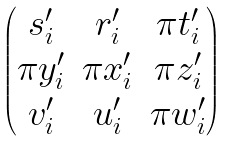Convert formula to latex. <formula><loc_0><loc_0><loc_500><loc_500>\begin{pmatrix} s _ { i } ^ { \prime } & r _ { i } ^ { \prime } & \pi t _ { i } ^ { \prime } \\ \pi y _ { i } ^ { \prime } & \pi x _ { i } ^ { \prime } & \pi z _ { i } ^ { \prime } \\ v _ { i } ^ { \prime } & u _ { i } ^ { \prime } & \pi w _ { i } ^ { \prime } \end{pmatrix}</formula> 